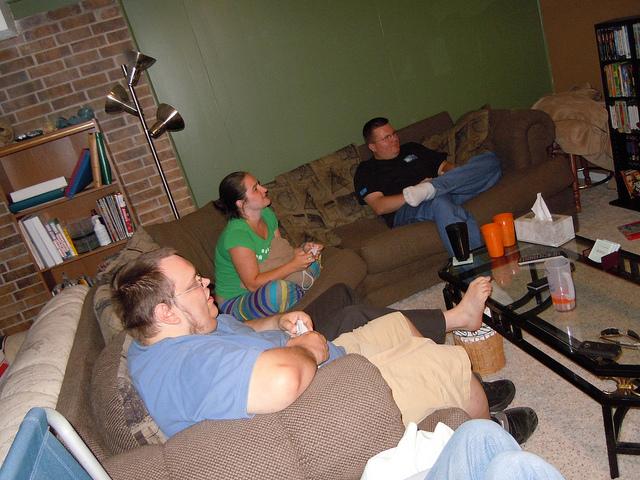What are these people doing?
Keep it brief. Watching tv. Are the people sitting?
Short answer required. Yes. How many people in this photo are sitting Indian-style?
Concise answer only. 1. 